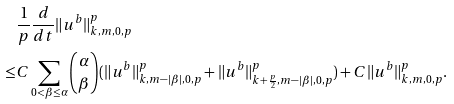Convert formula to latex. <formula><loc_0><loc_0><loc_500><loc_500>& \frac { 1 } { p } \frac { d } { d t } \| u ^ { b } \| ^ { p } _ { k , m , 0 , p } \\ \leq & C \sum _ { 0 < \beta \leq \alpha } \binom { \alpha } { \beta } ( \| u ^ { b } \| ^ { p } _ { k , m - | \beta | , 0 , p } + \| u ^ { b } \| ^ { p } _ { k + { \frac { p } { 2 } } , m - | \beta | , 0 , p } ) + C \| u ^ { b } \| ^ { p } _ { k , m , 0 , p } .</formula> 